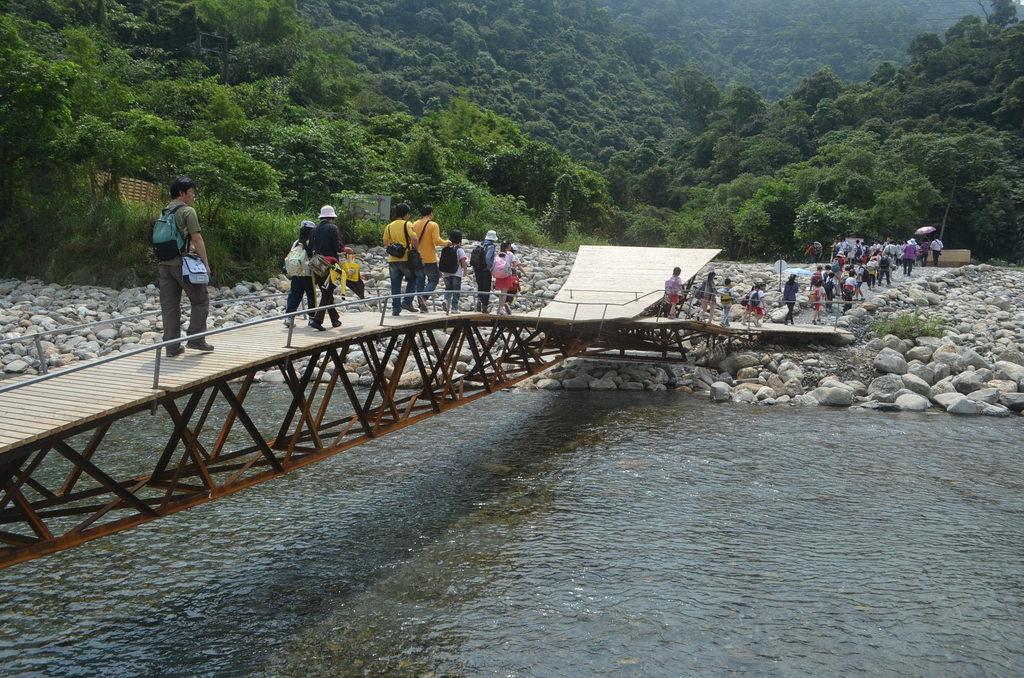Describe this image in one or two sentences. In this picture we can see the water, stones, some people carrying bags and walking on a bridge, some people on the ground and some objects and in the background we can see trees. 